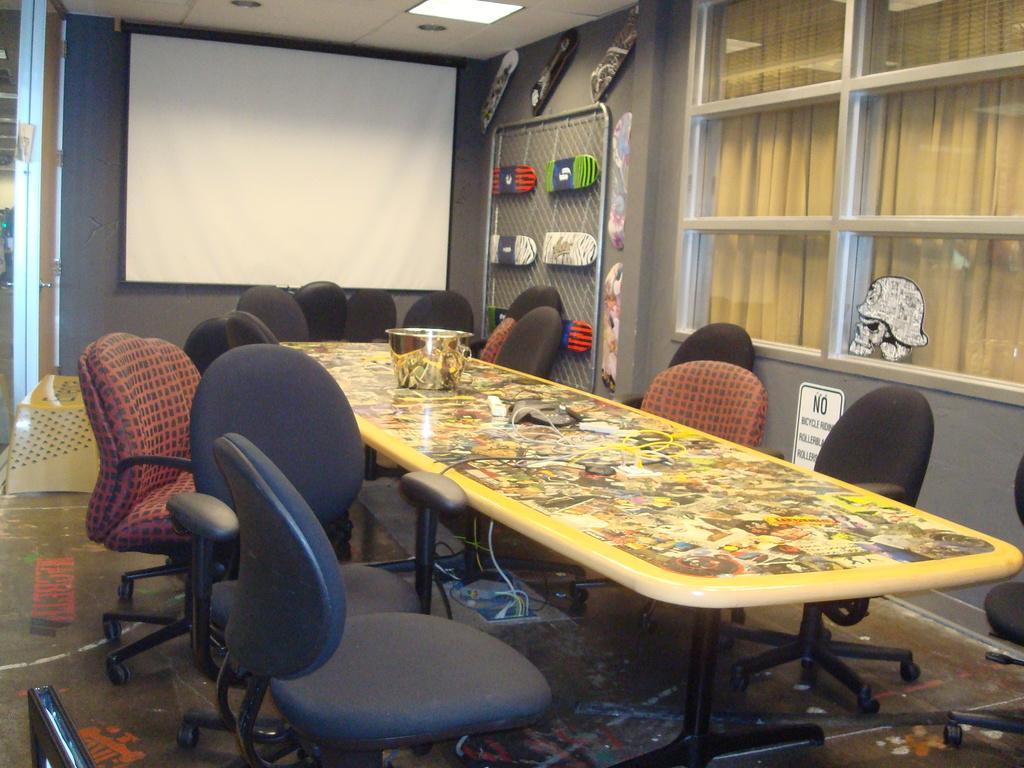Can you describe this image briefly? In the center of the image there is a table and we can see a vessel placed on the table. There are chairs. In the center there is a screen placed on the wall. On the right there is a window and we can see boards and a mesh placed on the wall. At the bottom there is a floor. At the top there is a light. 